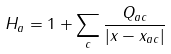Convert formula to latex. <formula><loc_0><loc_0><loc_500><loc_500>H _ { a } = 1 + \sum _ { c } \frac { Q _ { a c } } { | x - x _ { a c } | }</formula> 